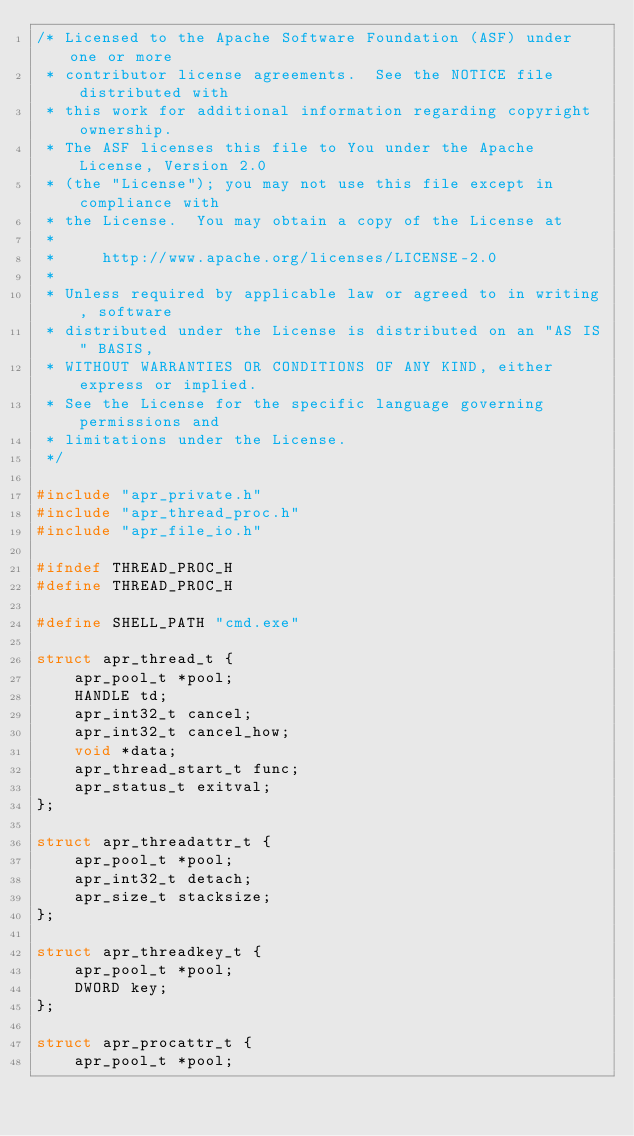<code> <loc_0><loc_0><loc_500><loc_500><_C_>/* Licensed to the Apache Software Foundation (ASF) under one or more
 * contributor license agreements.  See the NOTICE file distributed with
 * this work for additional information regarding copyright ownership.
 * The ASF licenses this file to You under the Apache License, Version 2.0
 * (the "License"); you may not use this file except in compliance with
 * the License.  You may obtain a copy of the License at
 *
 *     http://www.apache.org/licenses/LICENSE-2.0
 *
 * Unless required by applicable law or agreed to in writing, software
 * distributed under the License is distributed on an "AS IS" BASIS,
 * WITHOUT WARRANTIES OR CONDITIONS OF ANY KIND, either express or implied.
 * See the License for the specific language governing permissions and
 * limitations under the License.
 */

#include "apr_private.h"
#include "apr_thread_proc.h"
#include "apr_file_io.h"

#ifndef THREAD_PROC_H
#define THREAD_PROC_H

#define SHELL_PATH "cmd.exe"

struct apr_thread_t {
    apr_pool_t *pool;
    HANDLE td;
    apr_int32_t cancel;
    apr_int32_t cancel_how;
    void *data;
    apr_thread_start_t func;
    apr_status_t exitval;
};

struct apr_threadattr_t {
    apr_pool_t *pool;
    apr_int32_t detach;
    apr_size_t stacksize;
};

struct apr_threadkey_t {
    apr_pool_t *pool;
    DWORD key;
};

struct apr_procattr_t {
    apr_pool_t *pool;</code> 